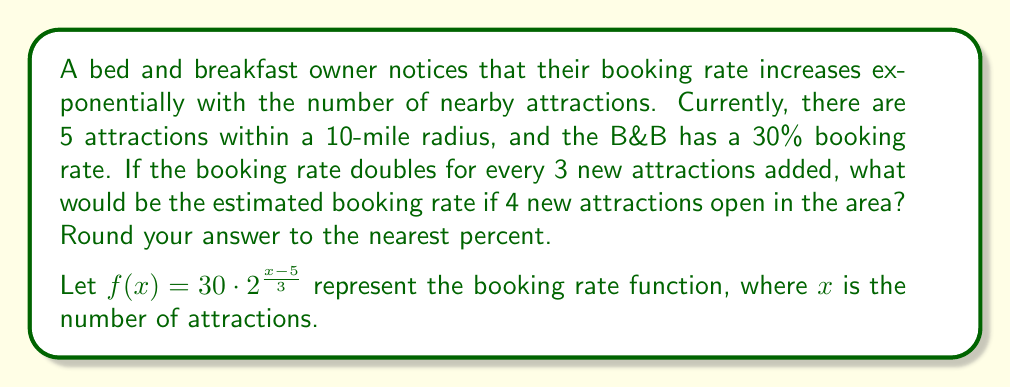Provide a solution to this math problem. To solve this problem, we'll follow these steps:

1) First, let's understand the given function:
   $f(x) = 30 \cdot 2^{\frac{x-5}{3}}$
   
   Here, 30 is the initial booking rate (30%), and the exponent $\frac{x-5}{3}$ represents how many times the rate has doubled from the initial 5 attractions.

2) We need to find $f(9)$, as there will be 9 attractions after 4 new ones open.

3) Let's substitute x = 9 into our function:
   $f(9) = 30 \cdot 2^{\frac{9-5}{3}}$

4) Simplify the exponent:
   $f(9) = 30 \cdot 2^{\frac{4}{3}}$

5) Calculate the power:
   $2^{\frac{4}{3}} \approx 2.5198$

6) Multiply:
   $f(9) = 30 \cdot 2.5198 \approx 75.5940$

7) Round to the nearest percent:
   75.5940% rounds to 76%

Therefore, the estimated booking rate with 9 attractions would be approximately 76%.
Answer: 76% 